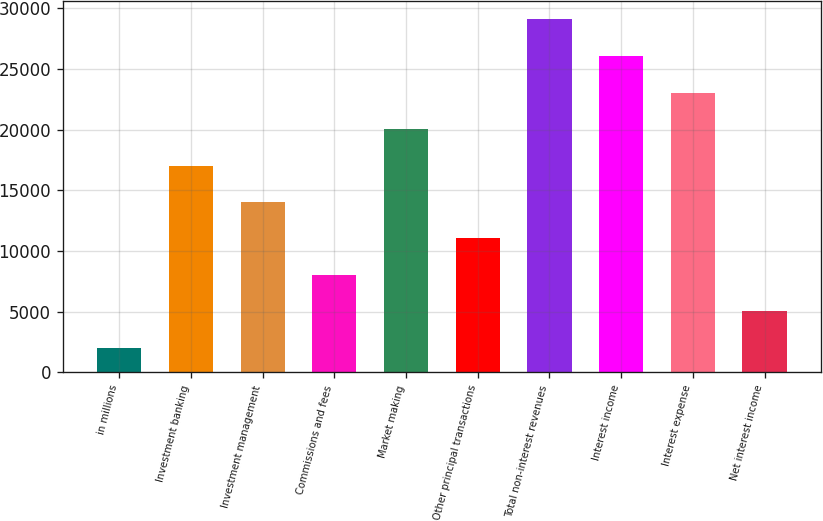Convert chart. <chart><loc_0><loc_0><loc_500><loc_500><bar_chart><fcel>in millions<fcel>Investment banking<fcel>Investment management<fcel>Commissions and fees<fcel>Market making<fcel>Other principal transactions<fcel>Total non-interest revenues<fcel>Interest income<fcel>Interest expense<fcel>Net interest income<nl><fcel>2017<fcel>17045<fcel>14039.4<fcel>8028.2<fcel>20050.6<fcel>11033.8<fcel>29141<fcel>26061.8<fcel>23056.2<fcel>5022.6<nl></chart> 